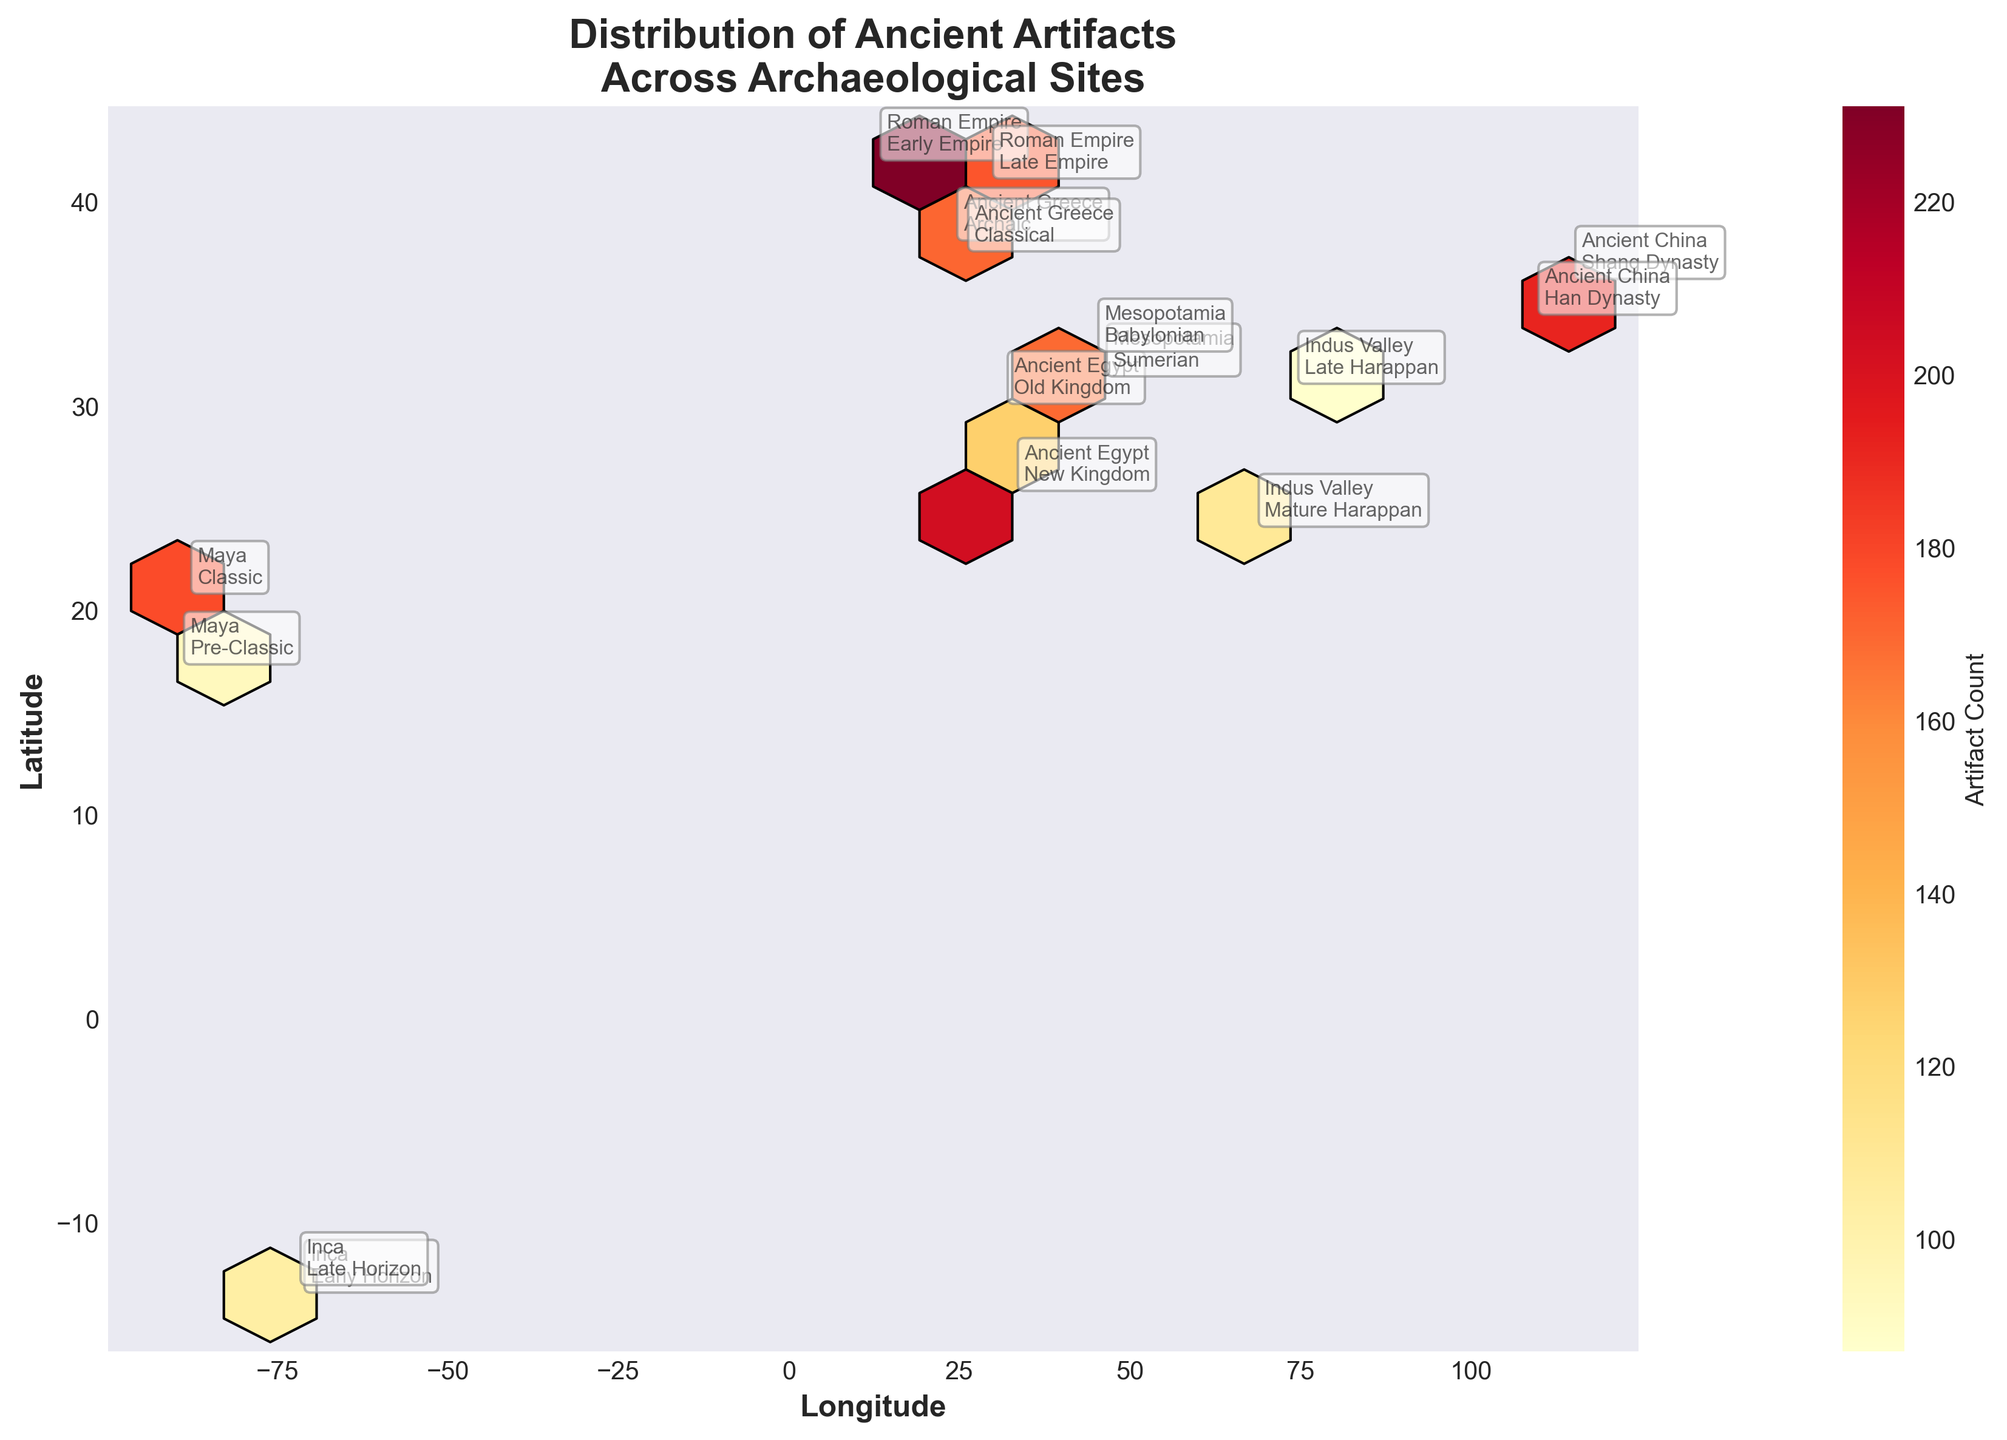Which civilization's archaeological sites displayed the highest artifact count? To determine the civilization with the highest artifact count, look at the color intensity of hexagons corresponding to the artifact count. The Roman Empire during the Early Empire period has the brightest color, indicating the highest count.
Answer: Roman Empire (Early Empire) Which two civilizations have the closest latitude but different artifact counts? Observe the positions of the annotated points with their corresponding civilizations. The Inca (Early Horizon) and Inca (Late Horizon) civilizations both occur around the same latitude (~-13.5) but have different artifact counts (76 and 131, respectively).
Answer: Inca (Early Horizon) and Inca (Late Horizon) Are there more ancient artifacts from the New Kingdom of Egypt or the Babylonian period in Mesopotamia? Compare the color intensities of the hexagons annotated with 'Ancient Egypt New Kingdom' and 'Mesopotamia Babylonian.' The New Kingdom of Egypt shows a brighter color than Babylonian Mesopotamia indicating a higher artifact count.
Answer: New Kingdom of Egypt Which region appears to be an overlapping area with high artifact counts from multiple civilizations? Identify the hexagons where multiple annotations are closely packed. The region around the latitude of 34 and longitude of 108 shows annotations from the Shang Dynasty and the Han Dynasty, indicating overlapping high artifact counts.
Answer: Region around latitude 34, longitude 108 (China) How does the artifact count at the Classical period in Ancient Greece compare to the Archaic period within the same civilization? Look at the color intensity of the hexagons corresponding to the Classical and Archaic periods of Ancient Greece. The Classical period shows a brighter hexagon than the Archaic period, indicating a higher artifact count.
Answer: Higher in the Classical period What is the general latitude range for the civilizations of Ancient China based on this plot? Observe the annotated points for Shang Dynasty and Han Dynasty, both related to Ancient China. They lie approximately between latitudes 34.3 and 36.1.
Answer: 34.3 to 36.1 For the Maya civilization, which period had a higher artifact count: Pre-Classic or Classic? Compare the color intensities of the hexagons corresponding to the 'Maya Pre-Classic' and 'Maya Classic' annotations. The 'Maya Classic' hexagon shows higher intensity, indicating a higher artifact count.
Answer: Classic What can be inferred about the site density for the Indus Valley civilization from the hexbin plot? Examine the hexagons at the points representing the Indus Valley (Mature Harappan and Late Harappan). The hexagons, although with different artifact counts, show that sites in the Indus Valley are somewhat clustered but less dense than some other regions.
Answer: Moderate site density Which civilization shows a broader longitude range for its sites: Ancient Greece or Rome? Observe the annotated points for each civilization. Ancient Greece has points around longitudes 23.7 to 25.3, while Rome has points from 12.5 to 28.98. Rome covers a broader longitude range.
Answer: Rome What relationship can be perceived between artifact count and the density of discovered sites? As the color intensity of hexagons increases, the hexbin plot indicates both higher artifact counts and higher site densities, implying a relationship where regions with more sites also tend to have higher artifact counts.
Answer: Higher counts with higher site density 